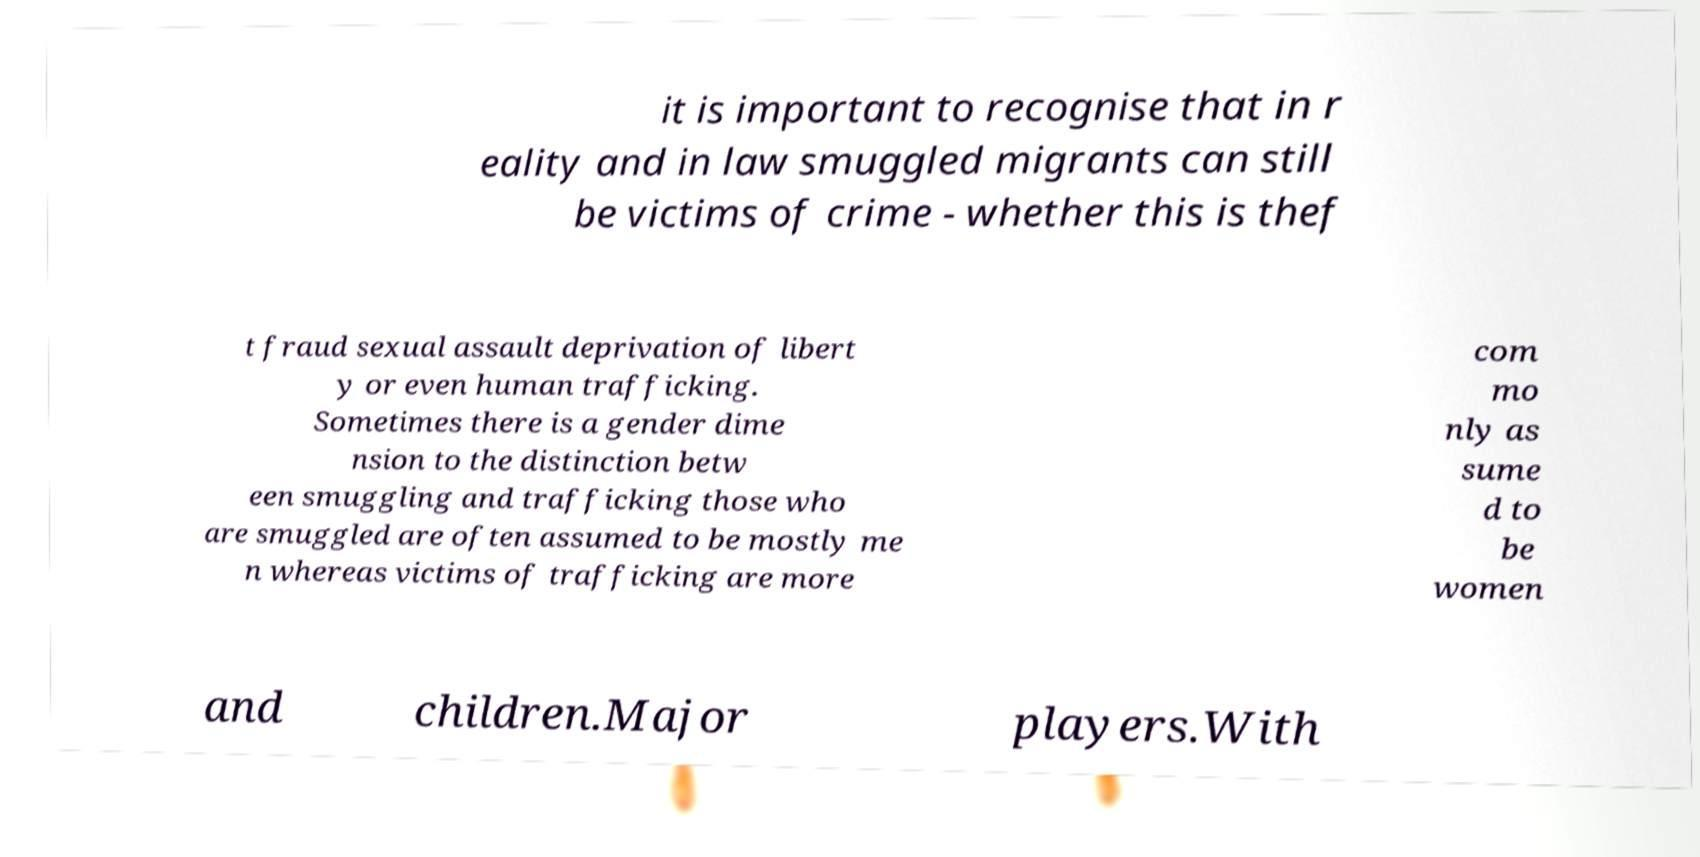Please read and relay the text visible in this image. What does it say? it is important to recognise that in r eality and in law smuggled migrants can still be victims of crime - whether this is thef t fraud sexual assault deprivation of libert y or even human trafficking. Sometimes there is a gender dime nsion to the distinction betw een smuggling and trafficking those who are smuggled are often assumed to be mostly me n whereas victims of trafficking are more com mo nly as sume d to be women and children.Major players.With 